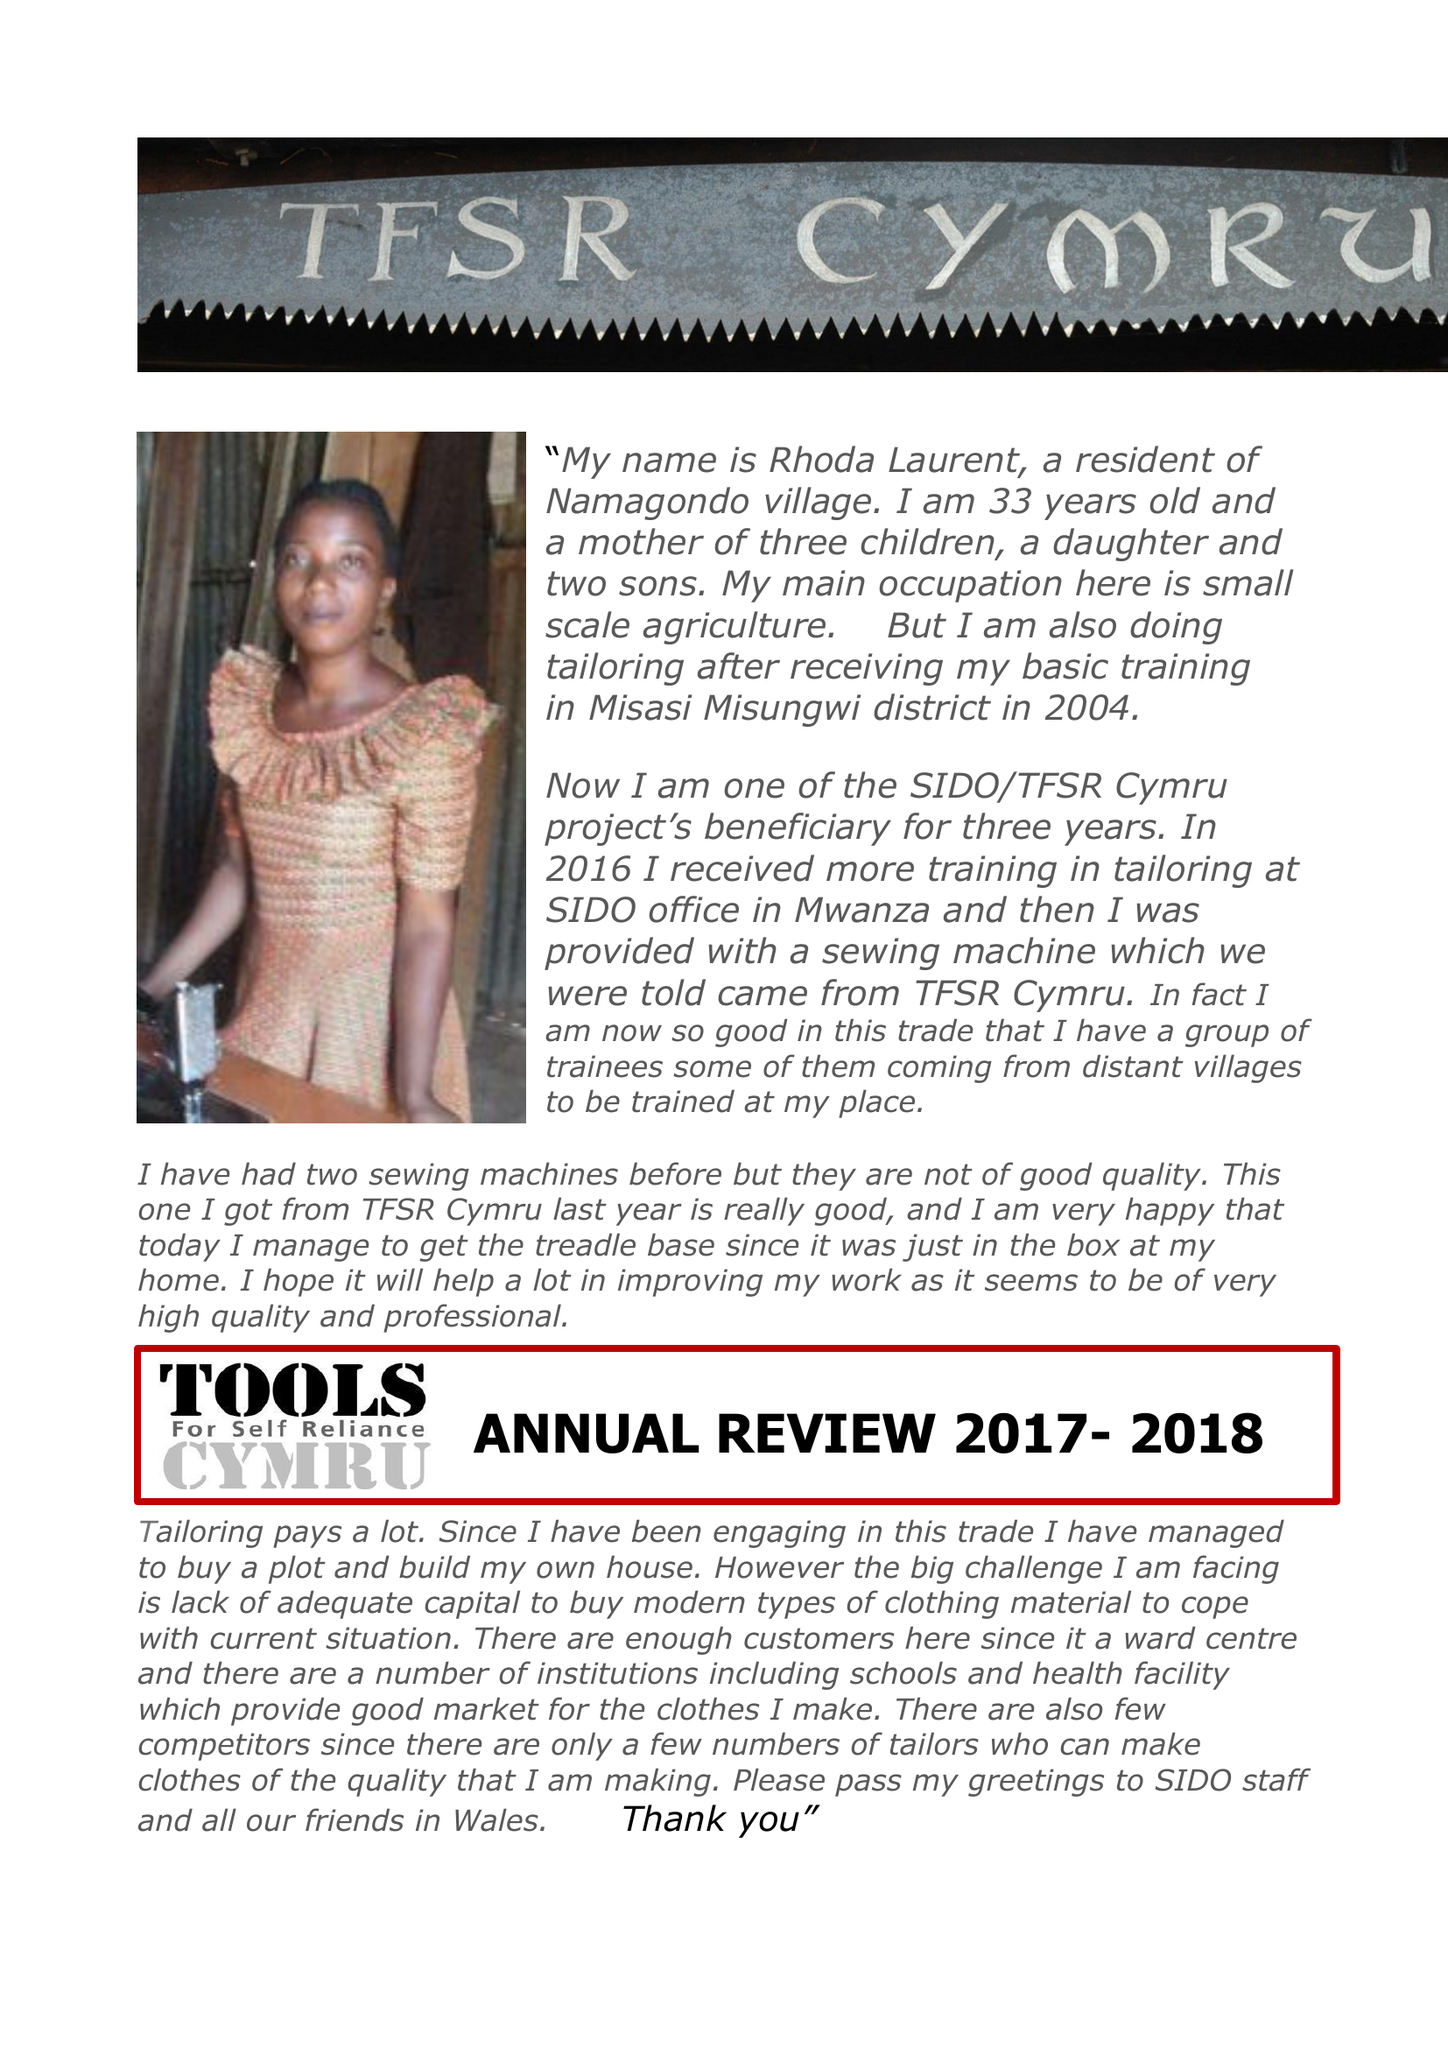What is the value for the address__post_town?
Answer the question using a single word or phrase. None 